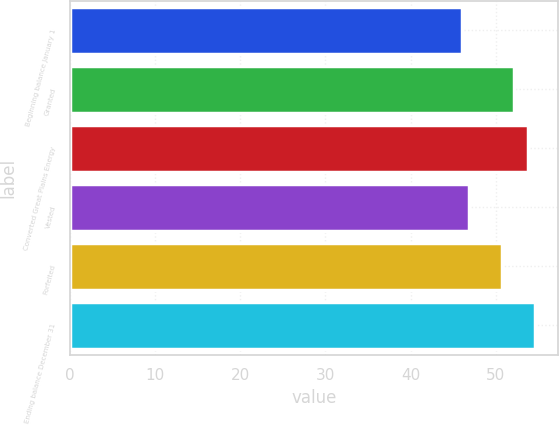<chart> <loc_0><loc_0><loc_500><loc_500><bar_chart><fcel>Beginning balance January 1<fcel>Granted<fcel>Converted Great Plains Energy<fcel>Vested<fcel>Forfeited<fcel>Ending balance December 31<nl><fcel>46.09<fcel>52.16<fcel>53.77<fcel>46.89<fcel>50.73<fcel>54.57<nl></chart> 